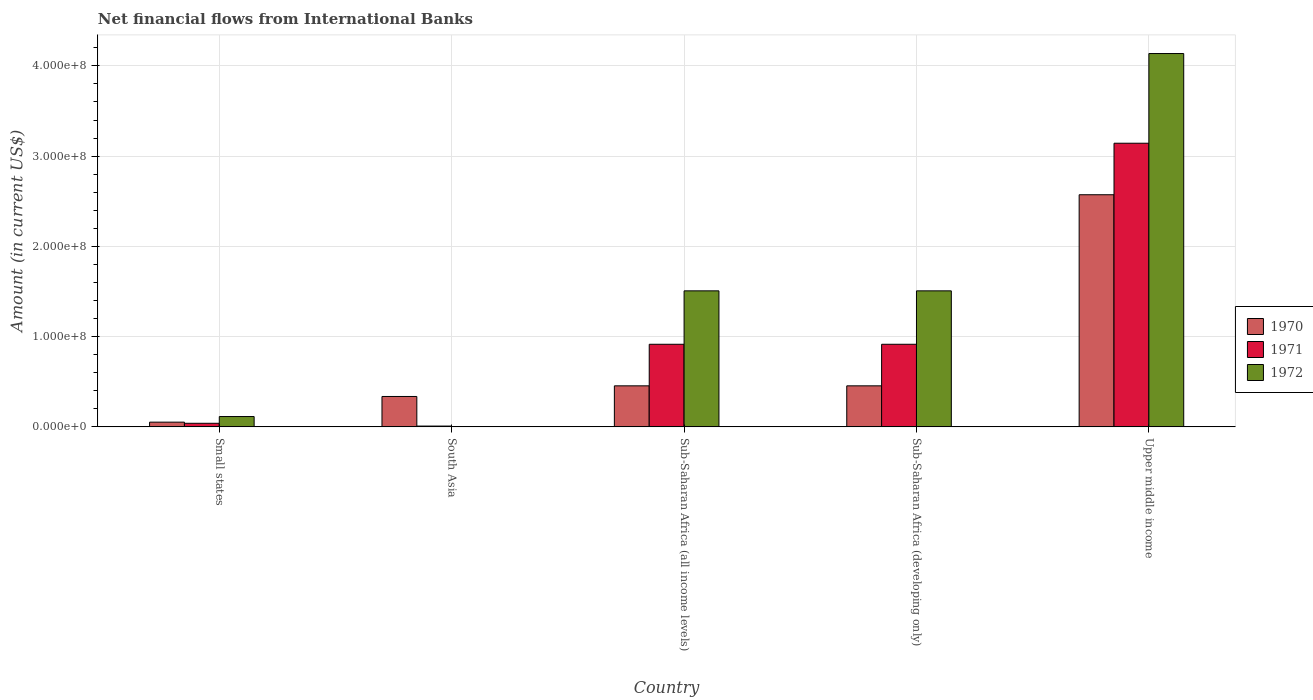Are the number of bars per tick equal to the number of legend labels?
Offer a terse response. No. Are the number of bars on each tick of the X-axis equal?
Offer a terse response. No. How many bars are there on the 3rd tick from the left?
Provide a succinct answer. 3. What is the label of the 1st group of bars from the left?
Provide a short and direct response. Small states. In how many cases, is the number of bars for a given country not equal to the number of legend labels?
Your answer should be compact. 1. What is the net financial aid flows in 1972 in South Asia?
Make the answer very short. 0. Across all countries, what is the maximum net financial aid flows in 1971?
Provide a short and direct response. 3.14e+08. Across all countries, what is the minimum net financial aid flows in 1972?
Keep it short and to the point. 0. In which country was the net financial aid flows in 1970 maximum?
Give a very brief answer. Upper middle income. What is the total net financial aid flows in 1970 in the graph?
Make the answer very short. 3.87e+08. What is the difference between the net financial aid flows in 1970 in Small states and that in Sub-Saharan Africa (developing only)?
Offer a terse response. -4.02e+07. What is the difference between the net financial aid flows in 1972 in South Asia and the net financial aid flows in 1971 in Upper middle income?
Keep it short and to the point. -3.14e+08. What is the average net financial aid flows in 1971 per country?
Keep it short and to the point. 1.00e+08. What is the difference between the net financial aid flows of/in 1971 and net financial aid flows of/in 1972 in Upper middle income?
Your response must be concise. -9.94e+07. What is the ratio of the net financial aid flows in 1970 in South Asia to that in Sub-Saharan Africa (developing only)?
Your response must be concise. 0.74. Is the difference between the net financial aid flows in 1971 in Sub-Saharan Africa (developing only) and Upper middle income greater than the difference between the net financial aid flows in 1972 in Sub-Saharan Africa (developing only) and Upper middle income?
Provide a short and direct response. Yes. What is the difference between the highest and the second highest net financial aid flows in 1971?
Offer a very short reply. 2.23e+08. What is the difference between the highest and the lowest net financial aid flows in 1970?
Your response must be concise. 2.52e+08. In how many countries, is the net financial aid flows in 1970 greater than the average net financial aid flows in 1970 taken over all countries?
Give a very brief answer. 1. How many countries are there in the graph?
Your answer should be compact. 5. What is the difference between two consecutive major ticks on the Y-axis?
Offer a very short reply. 1.00e+08. Are the values on the major ticks of Y-axis written in scientific E-notation?
Offer a very short reply. Yes. Where does the legend appear in the graph?
Your answer should be very brief. Center right. How many legend labels are there?
Provide a succinct answer. 3. How are the legend labels stacked?
Provide a succinct answer. Vertical. What is the title of the graph?
Ensure brevity in your answer.  Net financial flows from International Banks. Does "1985" appear as one of the legend labels in the graph?
Your response must be concise. No. What is the label or title of the X-axis?
Ensure brevity in your answer.  Country. What is the Amount (in current US$) of 1970 in Small states?
Your answer should be compact. 5.24e+06. What is the Amount (in current US$) in 1971 in Small states?
Keep it short and to the point. 3.97e+06. What is the Amount (in current US$) of 1972 in Small states?
Provide a short and direct response. 1.15e+07. What is the Amount (in current US$) in 1970 in South Asia?
Your answer should be very brief. 3.37e+07. What is the Amount (in current US$) in 1971 in South Asia?
Make the answer very short. 8.91e+05. What is the Amount (in current US$) of 1972 in South Asia?
Keep it short and to the point. 0. What is the Amount (in current US$) in 1970 in Sub-Saharan Africa (all income levels)?
Your response must be concise. 4.55e+07. What is the Amount (in current US$) in 1971 in Sub-Saharan Africa (all income levels)?
Make the answer very short. 9.15e+07. What is the Amount (in current US$) of 1972 in Sub-Saharan Africa (all income levels)?
Make the answer very short. 1.51e+08. What is the Amount (in current US$) in 1970 in Sub-Saharan Africa (developing only)?
Ensure brevity in your answer.  4.55e+07. What is the Amount (in current US$) of 1971 in Sub-Saharan Africa (developing only)?
Offer a terse response. 9.15e+07. What is the Amount (in current US$) in 1972 in Sub-Saharan Africa (developing only)?
Offer a very short reply. 1.51e+08. What is the Amount (in current US$) of 1970 in Upper middle income?
Ensure brevity in your answer.  2.57e+08. What is the Amount (in current US$) of 1971 in Upper middle income?
Ensure brevity in your answer.  3.14e+08. What is the Amount (in current US$) of 1972 in Upper middle income?
Offer a terse response. 4.14e+08. Across all countries, what is the maximum Amount (in current US$) of 1970?
Your answer should be very brief. 2.57e+08. Across all countries, what is the maximum Amount (in current US$) of 1971?
Your answer should be compact. 3.14e+08. Across all countries, what is the maximum Amount (in current US$) in 1972?
Make the answer very short. 4.14e+08. Across all countries, what is the minimum Amount (in current US$) in 1970?
Offer a terse response. 5.24e+06. Across all countries, what is the minimum Amount (in current US$) of 1971?
Make the answer very short. 8.91e+05. Across all countries, what is the minimum Amount (in current US$) in 1972?
Offer a very short reply. 0. What is the total Amount (in current US$) of 1970 in the graph?
Offer a very short reply. 3.87e+08. What is the total Amount (in current US$) of 1971 in the graph?
Make the answer very short. 5.02e+08. What is the total Amount (in current US$) in 1972 in the graph?
Offer a very short reply. 7.27e+08. What is the difference between the Amount (in current US$) in 1970 in Small states and that in South Asia?
Your answer should be very brief. -2.85e+07. What is the difference between the Amount (in current US$) of 1971 in Small states and that in South Asia?
Ensure brevity in your answer.  3.08e+06. What is the difference between the Amount (in current US$) of 1970 in Small states and that in Sub-Saharan Africa (all income levels)?
Keep it short and to the point. -4.02e+07. What is the difference between the Amount (in current US$) in 1971 in Small states and that in Sub-Saharan Africa (all income levels)?
Your answer should be compact. -8.76e+07. What is the difference between the Amount (in current US$) of 1972 in Small states and that in Sub-Saharan Africa (all income levels)?
Give a very brief answer. -1.39e+08. What is the difference between the Amount (in current US$) of 1970 in Small states and that in Sub-Saharan Africa (developing only)?
Offer a very short reply. -4.02e+07. What is the difference between the Amount (in current US$) of 1971 in Small states and that in Sub-Saharan Africa (developing only)?
Offer a very short reply. -8.76e+07. What is the difference between the Amount (in current US$) in 1972 in Small states and that in Sub-Saharan Africa (developing only)?
Give a very brief answer. -1.39e+08. What is the difference between the Amount (in current US$) of 1970 in Small states and that in Upper middle income?
Make the answer very short. -2.52e+08. What is the difference between the Amount (in current US$) of 1971 in Small states and that in Upper middle income?
Ensure brevity in your answer.  -3.10e+08. What is the difference between the Amount (in current US$) of 1972 in Small states and that in Upper middle income?
Ensure brevity in your answer.  -4.02e+08. What is the difference between the Amount (in current US$) in 1970 in South Asia and that in Sub-Saharan Africa (all income levels)?
Offer a very short reply. -1.18e+07. What is the difference between the Amount (in current US$) in 1971 in South Asia and that in Sub-Saharan Africa (all income levels)?
Ensure brevity in your answer.  -9.06e+07. What is the difference between the Amount (in current US$) in 1970 in South Asia and that in Sub-Saharan Africa (developing only)?
Your answer should be very brief. -1.18e+07. What is the difference between the Amount (in current US$) in 1971 in South Asia and that in Sub-Saharan Africa (developing only)?
Give a very brief answer. -9.06e+07. What is the difference between the Amount (in current US$) of 1970 in South Asia and that in Upper middle income?
Ensure brevity in your answer.  -2.24e+08. What is the difference between the Amount (in current US$) of 1971 in South Asia and that in Upper middle income?
Provide a succinct answer. -3.13e+08. What is the difference between the Amount (in current US$) in 1970 in Sub-Saharan Africa (all income levels) and that in Sub-Saharan Africa (developing only)?
Provide a short and direct response. 0. What is the difference between the Amount (in current US$) in 1971 in Sub-Saharan Africa (all income levels) and that in Sub-Saharan Africa (developing only)?
Your answer should be very brief. 0. What is the difference between the Amount (in current US$) of 1972 in Sub-Saharan Africa (all income levels) and that in Sub-Saharan Africa (developing only)?
Provide a succinct answer. 0. What is the difference between the Amount (in current US$) in 1970 in Sub-Saharan Africa (all income levels) and that in Upper middle income?
Offer a terse response. -2.12e+08. What is the difference between the Amount (in current US$) of 1971 in Sub-Saharan Africa (all income levels) and that in Upper middle income?
Provide a succinct answer. -2.23e+08. What is the difference between the Amount (in current US$) of 1972 in Sub-Saharan Africa (all income levels) and that in Upper middle income?
Keep it short and to the point. -2.63e+08. What is the difference between the Amount (in current US$) in 1970 in Sub-Saharan Africa (developing only) and that in Upper middle income?
Your response must be concise. -2.12e+08. What is the difference between the Amount (in current US$) in 1971 in Sub-Saharan Africa (developing only) and that in Upper middle income?
Your answer should be compact. -2.23e+08. What is the difference between the Amount (in current US$) of 1972 in Sub-Saharan Africa (developing only) and that in Upper middle income?
Your answer should be compact. -2.63e+08. What is the difference between the Amount (in current US$) of 1970 in Small states and the Amount (in current US$) of 1971 in South Asia?
Ensure brevity in your answer.  4.34e+06. What is the difference between the Amount (in current US$) of 1970 in Small states and the Amount (in current US$) of 1971 in Sub-Saharan Africa (all income levels)?
Provide a succinct answer. -8.63e+07. What is the difference between the Amount (in current US$) of 1970 in Small states and the Amount (in current US$) of 1972 in Sub-Saharan Africa (all income levels)?
Give a very brief answer. -1.45e+08. What is the difference between the Amount (in current US$) in 1971 in Small states and the Amount (in current US$) in 1972 in Sub-Saharan Africa (all income levels)?
Make the answer very short. -1.47e+08. What is the difference between the Amount (in current US$) of 1970 in Small states and the Amount (in current US$) of 1971 in Sub-Saharan Africa (developing only)?
Your answer should be very brief. -8.63e+07. What is the difference between the Amount (in current US$) of 1970 in Small states and the Amount (in current US$) of 1972 in Sub-Saharan Africa (developing only)?
Your answer should be very brief. -1.45e+08. What is the difference between the Amount (in current US$) in 1971 in Small states and the Amount (in current US$) in 1972 in Sub-Saharan Africa (developing only)?
Make the answer very short. -1.47e+08. What is the difference between the Amount (in current US$) of 1970 in Small states and the Amount (in current US$) of 1971 in Upper middle income?
Your answer should be very brief. -3.09e+08. What is the difference between the Amount (in current US$) of 1970 in Small states and the Amount (in current US$) of 1972 in Upper middle income?
Ensure brevity in your answer.  -4.08e+08. What is the difference between the Amount (in current US$) in 1971 in Small states and the Amount (in current US$) in 1972 in Upper middle income?
Ensure brevity in your answer.  -4.10e+08. What is the difference between the Amount (in current US$) of 1970 in South Asia and the Amount (in current US$) of 1971 in Sub-Saharan Africa (all income levels)?
Your answer should be very brief. -5.78e+07. What is the difference between the Amount (in current US$) of 1970 in South Asia and the Amount (in current US$) of 1972 in Sub-Saharan Africa (all income levels)?
Make the answer very short. -1.17e+08. What is the difference between the Amount (in current US$) in 1971 in South Asia and the Amount (in current US$) in 1972 in Sub-Saharan Africa (all income levels)?
Your answer should be compact. -1.50e+08. What is the difference between the Amount (in current US$) in 1970 in South Asia and the Amount (in current US$) in 1971 in Sub-Saharan Africa (developing only)?
Provide a succinct answer. -5.78e+07. What is the difference between the Amount (in current US$) in 1970 in South Asia and the Amount (in current US$) in 1972 in Sub-Saharan Africa (developing only)?
Provide a succinct answer. -1.17e+08. What is the difference between the Amount (in current US$) of 1971 in South Asia and the Amount (in current US$) of 1972 in Sub-Saharan Africa (developing only)?
Keep it short and to the point. -1.50e+08. What is the difference between the Amount (in current US$) of 1970 in South Asia and the Amount (in current US$) of 1971 in Upper middle income?
Your answer should be compact. -2.81e+08. What is the difference between the Amount (in current US$) of 1970 in South Asia and the Amount (in current US$) of 1972 in Upper middle income?
Make the answer very short. -3.80e+08. What is the difference between the Amount (in current US$) of 1971 in South Asia and the Amount (in current US$) of 1972 in Upper middle income?
Offer a terse response. -4.13e+08. What is the difference between the Amount (in current US$) of 1970 in Sub-Saharan Africa (all income levels) and the Amount (in current US$) of 1971 in Sub-Saharan Africa (developing only)?
Make the answer very short. -4.61e+07. What is the difference between the Amount (in current US$) of 1970 in Sub-Saharan Africa (all income levels) and the Amount (in current US$) of 1972 in Sub-Saharan Africa (developing only)?
Offer a very short reply. -1.05e+08. What is the difference between the Amount (in current US$) of 1971 in Sub-Saharan Africa (all income levels) and the Amount (in current US$) of 1972 in Sub-Saharan Africa (developing only)?
Provide a short and direct response. -5.92e+07. What is the difference between the Amount (in current US$) of 1970 in Sub-Saharan Africa (all income levels) and the Amount (in current US$) of 1971 in Upper middle income?
Your answer should be compact. -2.69e+08. What is the difference between the Amount (in current US$) of 1970 in Sub-Saharan Africa (all income levels) and the Amount (in current US$) of 1972 in Upper middle income?
Offer a terse response. -3.68e+08. What is the difference between the Amount (in current US$) of 1971 in Sub-Saharan Africa (all income levels) and the Amount (in current US$) of 1972 in Upper middle income?
Your answer should be very brief. -3.22e+08. What is the difference between the Amount (in current US$) in 1970 in Sub-Saharan Africa (developing only) and the Amount (in current US$) in 1971 in Upper middle income?
Ensure brevity in your answer.  -2.69e+08. What is the difference between the Amount (in current US$) in 1970 in Sub-Saharan Africa (developing only) and the Amount (in current US$) in 1972 in Upper middle income?
Your answer should be compact. -3.68e+08. What is the difference between the Amount (in current US$) in 1971 in Sub-Saharan Africa (developing only) and the Amount (in current US$) in 1972 in Upper middle income?
Provide a short and direct response. -3.22e+08. What is the average Amount (in current US$) of 1970 per country?
Your answer should be very brief. 7.74e+07. What is the average Amount (in current US$) in 1971 per country?
Ensure brevity in your answer.  1.00e+08. What is the average Amount (in current US$) of 1972 per country?
Offer a terse response. 1.45e+08. What is the difference between the Amount (in current US$) in 1970 and Amount (in current US$) in 1971 in Small states?
Keep it short and to the point. 1.27e+06. What is the difference between the Amount (in current US$) of 1970 and Amount (in current US$) of 1972 in Small states?
Your answer should be compact. -6.22e+06. What is the difference between the Amount (in current US$) in 1971 and Amount (in current US$) in 1972 in Small states?
Provide a succinct answer. -7.49e+06. What is the difference between the Amount (in current US$) in 1970 and Amount (in current US$) in 1971 in South Asia?
Keep it short and to the point. 3.28e+07. What is the difference between the Amount (in current US$) in 1970 and Amount (in current US$) in 1971 in Sub-Saharan Africa (all income levels)?
Offer a very short reply. -4.61e+07. What is the difference between the Amount (in current US$) of 1970 and Amount (in current US$) of 1972 in Sub-Saharan Africa (all income levels)?
Give a very brief answer. -1.05e+08. What is the difference between the Amount (in current US$) in 1971 and Amount (in current US$) in 1972 in Sub-Saharan Africa (all income levels)?
Offer a terse response. -5.92e+07. What is the difference between the Amount (in current US$) of 1970 and Amount (in current US$) of 1971 in Sub-Saharan Africa (developing only)?
Offer a very short reply. -4.61e+07. What is the difference between the Amount (in current US$) of 1970 and Amount (in current US$) of 1972 in Sub-Saharan Africa (developing only)?
Offer a terse response. -1.05e+08. What is the difference between the Amount (in current US$) in 1971 and Amount (in current US$) in 1972 in Sub-Saharan Africa (developing only)?
Make the answer very short. -5.92e+07. What is the difference between the Amount (in current US$) in 1970 and Amount (in current US$) in 1971 in Upper middle income?
Offer a very short reply. -5.71e+07. What is the difference between the Amount (in current US$) in 1970 and Amount (in current US$) in 1972 in Upper middle income?
Give a very brief answer. -1.56e+08. What is the difference between the Amount (in current US$) in 1971 and Amount (in current US$) in 1972 in Upper middle income?
Make the answer very short. -9.94e+07. What is the ratio of the Amount (in current US$) in 1970 in Small states to that in South Asia?
Your response must be concise. 0.16. What is the ratio of the Amount (in current US$) in 1971 in Small states to that in South Asia?
Your answer should be compact. 4.45. What is the ratio of the Amount (in current US$) of 1970 in Small states to that in Sub-Saharan Africa (all income levels)?
Provide a short and direct response. 0.12. What is the ratio of the Amount (in current US$) of 1971 in Small states to that in Sub-Saharan Africa (all income levels)?
Make the answer very short. 0.04. What is the ratio of the Amount (in current US$) of 1972 in Small states to that in Sub-Saharan Africa (all income levels)?
Your answer should be very brief. 0.08. What is the ratio of the Amount (in current US$) in 1970 in Small states to that in Sub-Saharan Africa (developing only)?
Ensure brevity in your answer.  0.12. What is the ratio of the Amount (in current US$) of 1971 in Small states to that in Sub-Saharan Africa (developing only)?
Ensure brevity in your answer.  0.04. What is the ratio of the Amount (in current US$) in 1972 in Small states to that in Sub-Saharan Africa (developing only)?
Ensure brevity in your answer.  0.08. What is the ratio of the Amount (in current US$) of 1970 in Small states to that in Upper middle income?
Your response must be concise. 0.02. What is the ratio of the Amount (in current US$) in 1971 in Small states to that in Upper middle income?
Your answer should be very brief. 0.01. What is the ratio of the Amount (in current US$) of 1972 in Small states to that in Upper middle income?
Offer a terse response. 0.03. What is the ratio of the Amount (in current US$) in 1970 in South Asia to that in Sub-Saharan Africa (all income levels)?
Give a very brief answer. 0.74. What is the ratio of the Amount (in current US$) in 1971 in South Asia to that in Sub-Saharan Africa (all income levels)?
Offer a very short reply. 0.01. What is the ratio of the Amount (in current US$) of 1970 in South Asia to that in Sub-Saharan Africa (developing only)?
Provide a short and direct response. 0.74. What is the ratio of the Amount (in current US$) of 1971 in South Asia to that in Sub-Saharan Africa (developing only)?
Offer a very short reply. 0.01. What is the ratio of the Amount (in current US$) in 1970 in South Asia to that in Upper middle income?
Offer a very short reply. 0.13. What is the ratio of the Amount (in current US$) of 1971 in South Asia to that in Upper middle income?
Your response must be concise. 0. What is the ratio of the Amount (in current US$) of 1970 in Sub-Saharan Africa (all income levels) to that in Sub-Saharan Africa (developing only)?
Provide a succinct answer. 1. What is the ratio of the Amount (in current US$) of 1972 in Sub-Saharan Africa (all income levels) to that in Sub-Saharan Africa (developing only)?
Your response must be concise. 1. What is the ratio of the Amount (in current US$) of 1970 in Sub-Saharan Africa (all income levels) to that in Upper middle income?
Your answer should be compact. 0.18. What is the ratio of the Amount (in current US$) in 1971 in Sub-Saharan Africa (all income levels) to that in Upper middle income?
Your response must be concise. 0.29. What is the ratio of the Amount (in current US$) of 1972 in Sub-Saharan Africa (all income levels) to that in Upper middle income?
Provide a short and direct response. 0.36. What is the ratio of the Amount (in current US$) of 1970 in Sub-Saharan Africa (developing only) to that in Upper middle income?
Your answer should be compact. 0.18. What is the ratio of the Amount (in current US$) of 1971 in Sub-Saharan Africa (developing only) to that in Upper middle income?
Your answer should be compact. 0.29. What is the ratio of the Amount (in current US$) in 1972 in Sub-Saharan Africa (developing only) to that in Upper middle income?
Your answer should be very brief. 0.36. What is the difference between the highest and the second highest Amount (in current US$) in 1970?
Make the answer very short. 2.12e+08. What is the difference between the highest and the second highest Amount (in current US$) in 1971?
Your response must be concise. 2.23e+08. What is the difference between the highest and the second highest Amount (in current US$) of 1972?
Ensure brevity in your answer.  2.63e+08. What is the difference between the highest and the lowest Amount (in current US$) of 1970?
Keep it short and to the point. 2.52e+08. What is the difference between the highest and the lowest Amount (in current US$) in 1971?
Your answer should be very brief. 3.13e+08. What is the difference between the highest and the lowest Amount (in current US$) in 1972?
Offer a very short reply. 4.14e+08. 